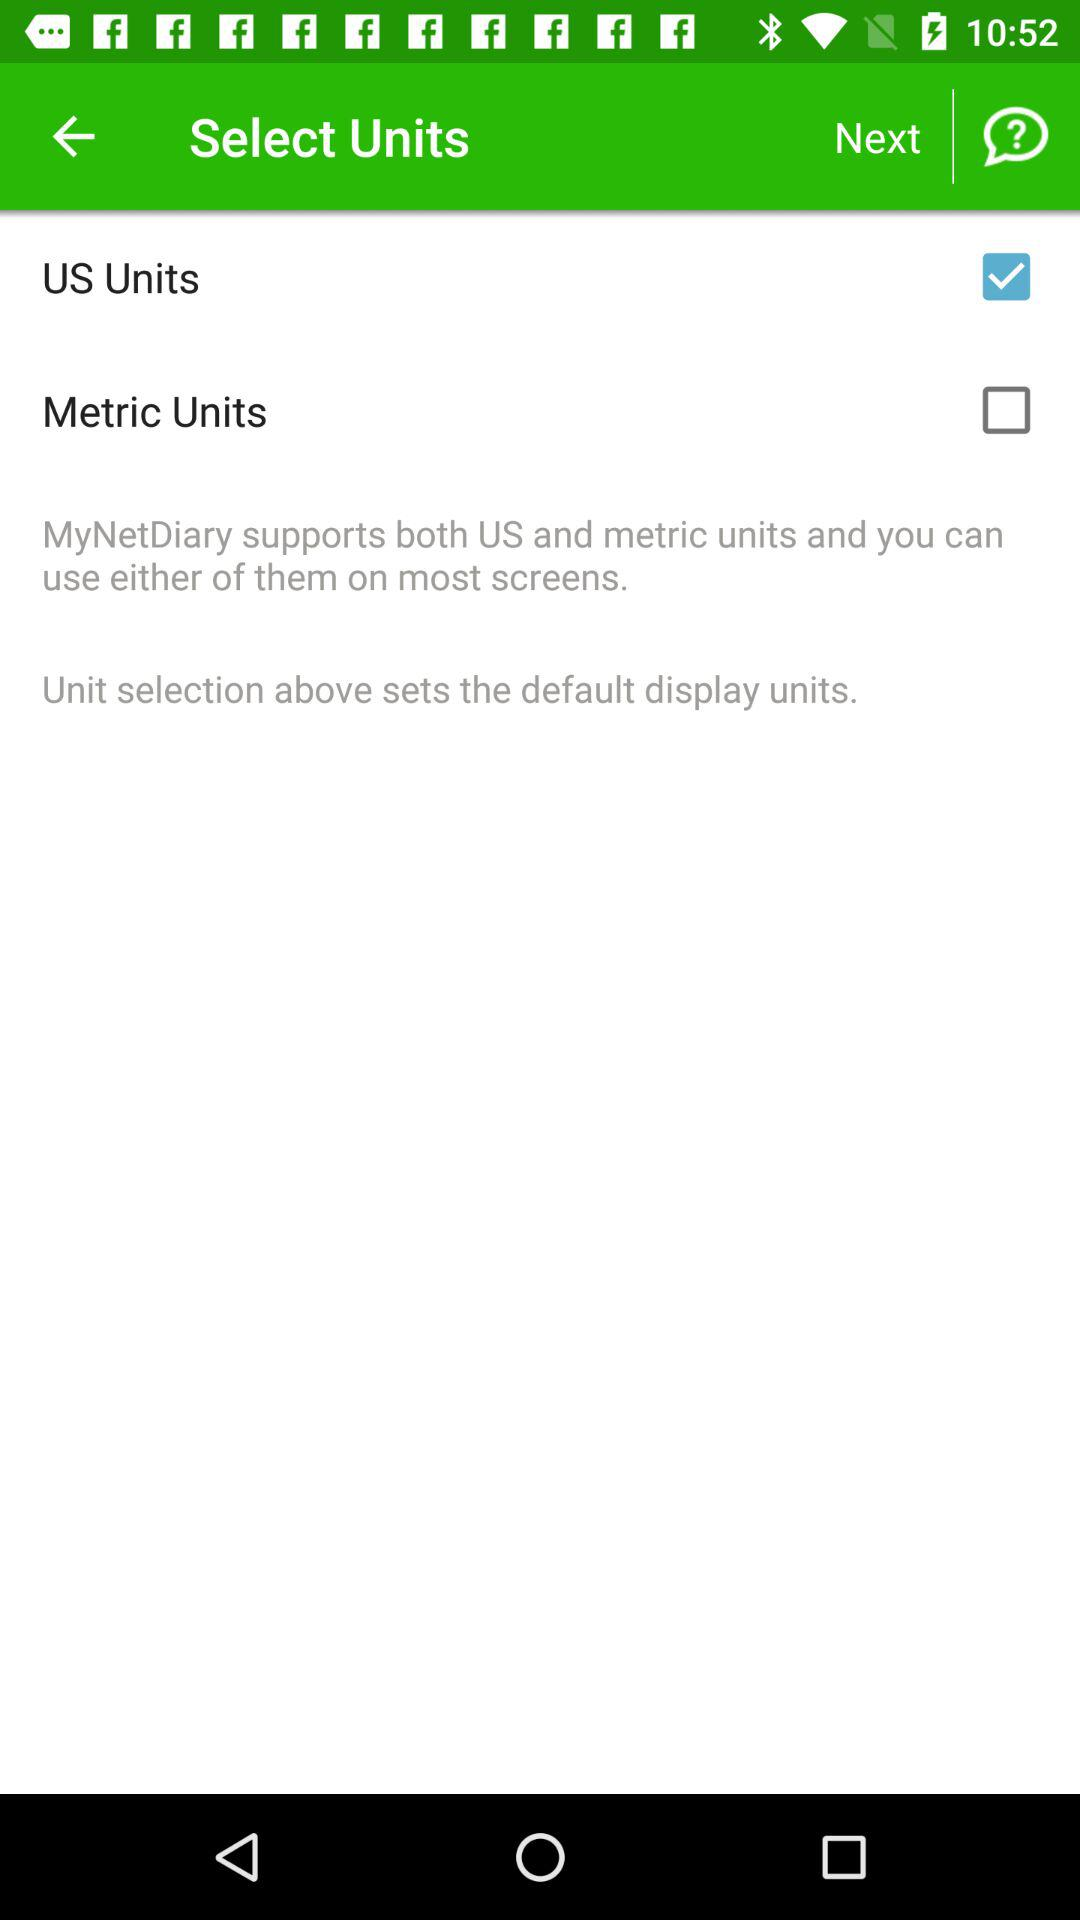What is the status of the "Metric Units"? The status is "off". 